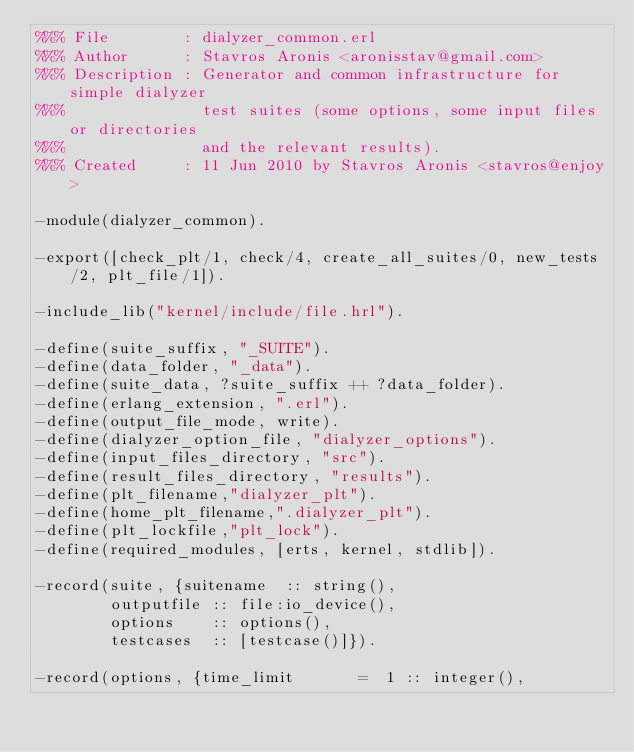<code> <loc_0><loc_0><loc_500><loc_500><_Erlang_>%%% File        : dialyzer_common.erl
%%% Author      : Stavros Aronis <aronisstav@gmail.com>
%%% Description : Generator and common infrastructure for simple dialyzer
%%%               test suites (some options, some input files or directories
%%%               and the relevant results).
%%% Created     : 11 Jun 2010 by Stavros Aronis <stavros@enjoy>

-module(dialyzer_common).

-export([check_plt/1, check/4, create_all_suites/0, new_tests/2, plt_file/1]).

-include_lib("kernel/include/file.hrl").

-define(suite_suffix, "_SUITE").
-define(data_folder, "_data").
-define(suite_data, ?suite_suffix ++ ?data_folder).
-define(erlang_extension, ".erl").
-define(output_file_mode, write).
-define(dialyzer_option_file, "dialyzer_options").
-define(input_files_directory, "src").
-define(result_files_directory, "results").
-define(plt_filename,"dialyzer_plt").
-define(home_plt_filename,".dialyzer_plt").
-define(plt_lockfile,"plt_lock").
-define(required_modules, [erts, kernel, stdlib]).

-record(suite, {suitename  :: string(),
		outputfile :: file:io_device(),
		options    :: options(),
		testcases  :: [testcase()]}).

-record(options, {time_limit       =  1 :: integer(),</code> 